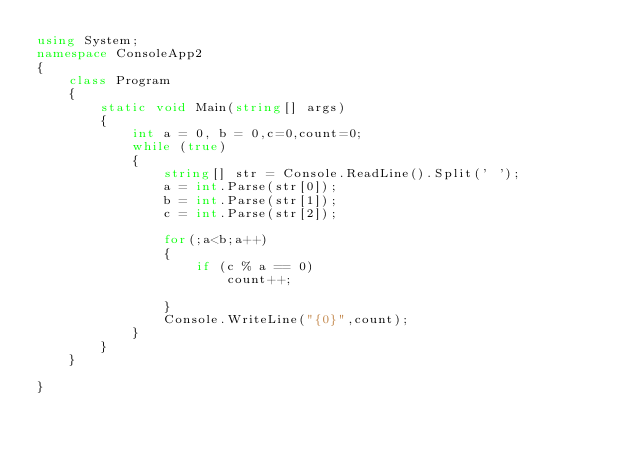Convert code to text. <code><loc_0><loc_0><loc_500><loc_500><_C#_>using System;
namespace ConsoleApp2
{
    class Program
    {
        static void Main(string[] args)
        {
            int a = 0, b = 0,c=0,count=0;
            while (true)
            {
                string[] str = Console.ReadLine().Split(' ');
                a = int.Parse(str[0]);
                b = int.Parse(str[1]);
                c = int.Parse(str[2]);

                for(;a<b;a++)
                {
                    if (c % a == 0)
                        count++;

                }
                Console.WriteLine("{0}",count);
            }
        }
    }
    
}

</code> 